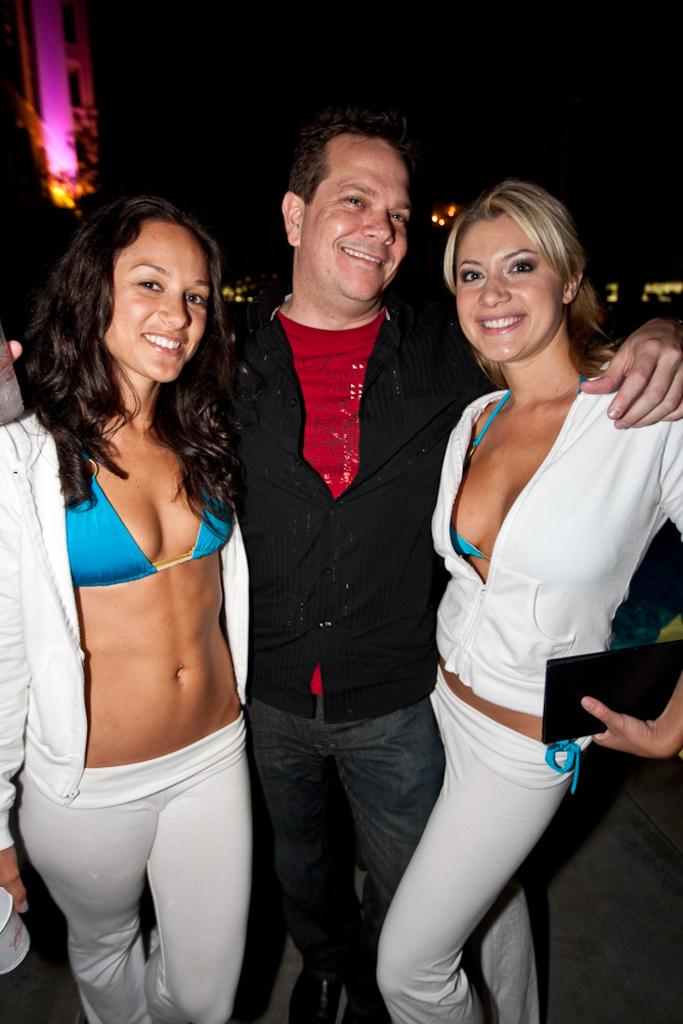How many people are present in the image? There are three people in the image: two women and one man. Can you describe the lighting in the image? There is darkness behind the people in the image. How many fingers does the quiet person have in the image? There is no mention of a quiet person in the image, and therefore no such information about their fingers can be provided. 